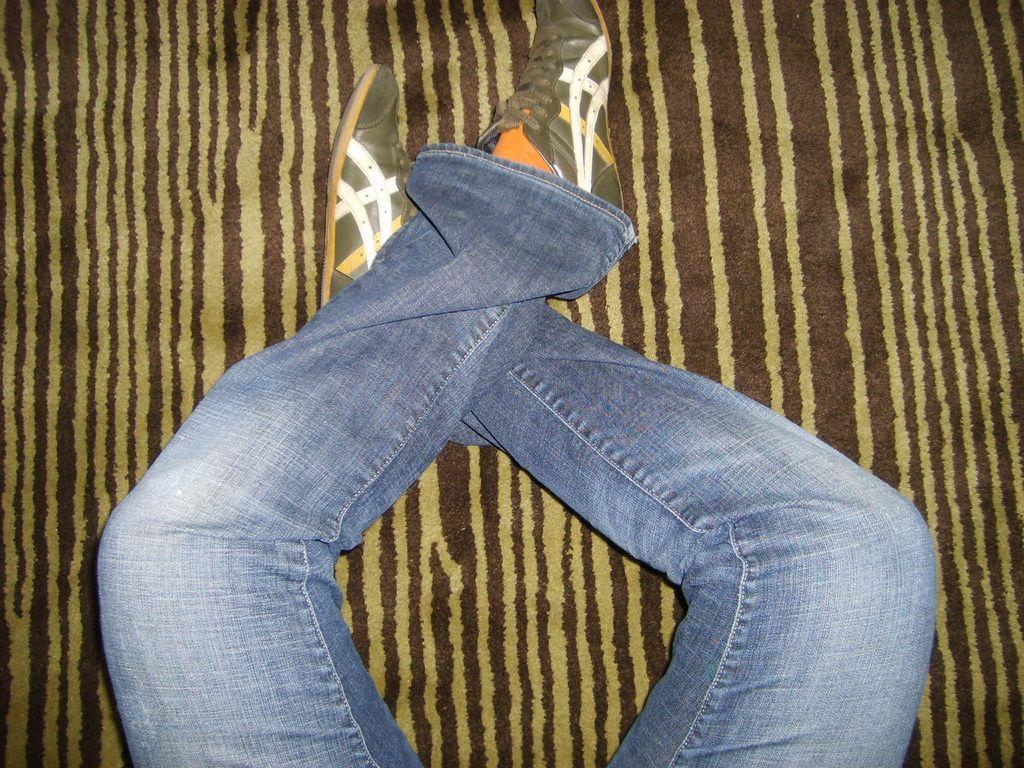What part of a person can be seen in the image? There are legs of a person visible in the image. What type of footwear is the person wearing? The person is wearing shoes. What type of clothing is the person wearing on their legs? The person is wearing denim jeans. What can be seen in the background of the image? There is a cloth in the background of the image. What type of pest is causing damage to the appliance in the image? There is no appliance or pest present in the image. 